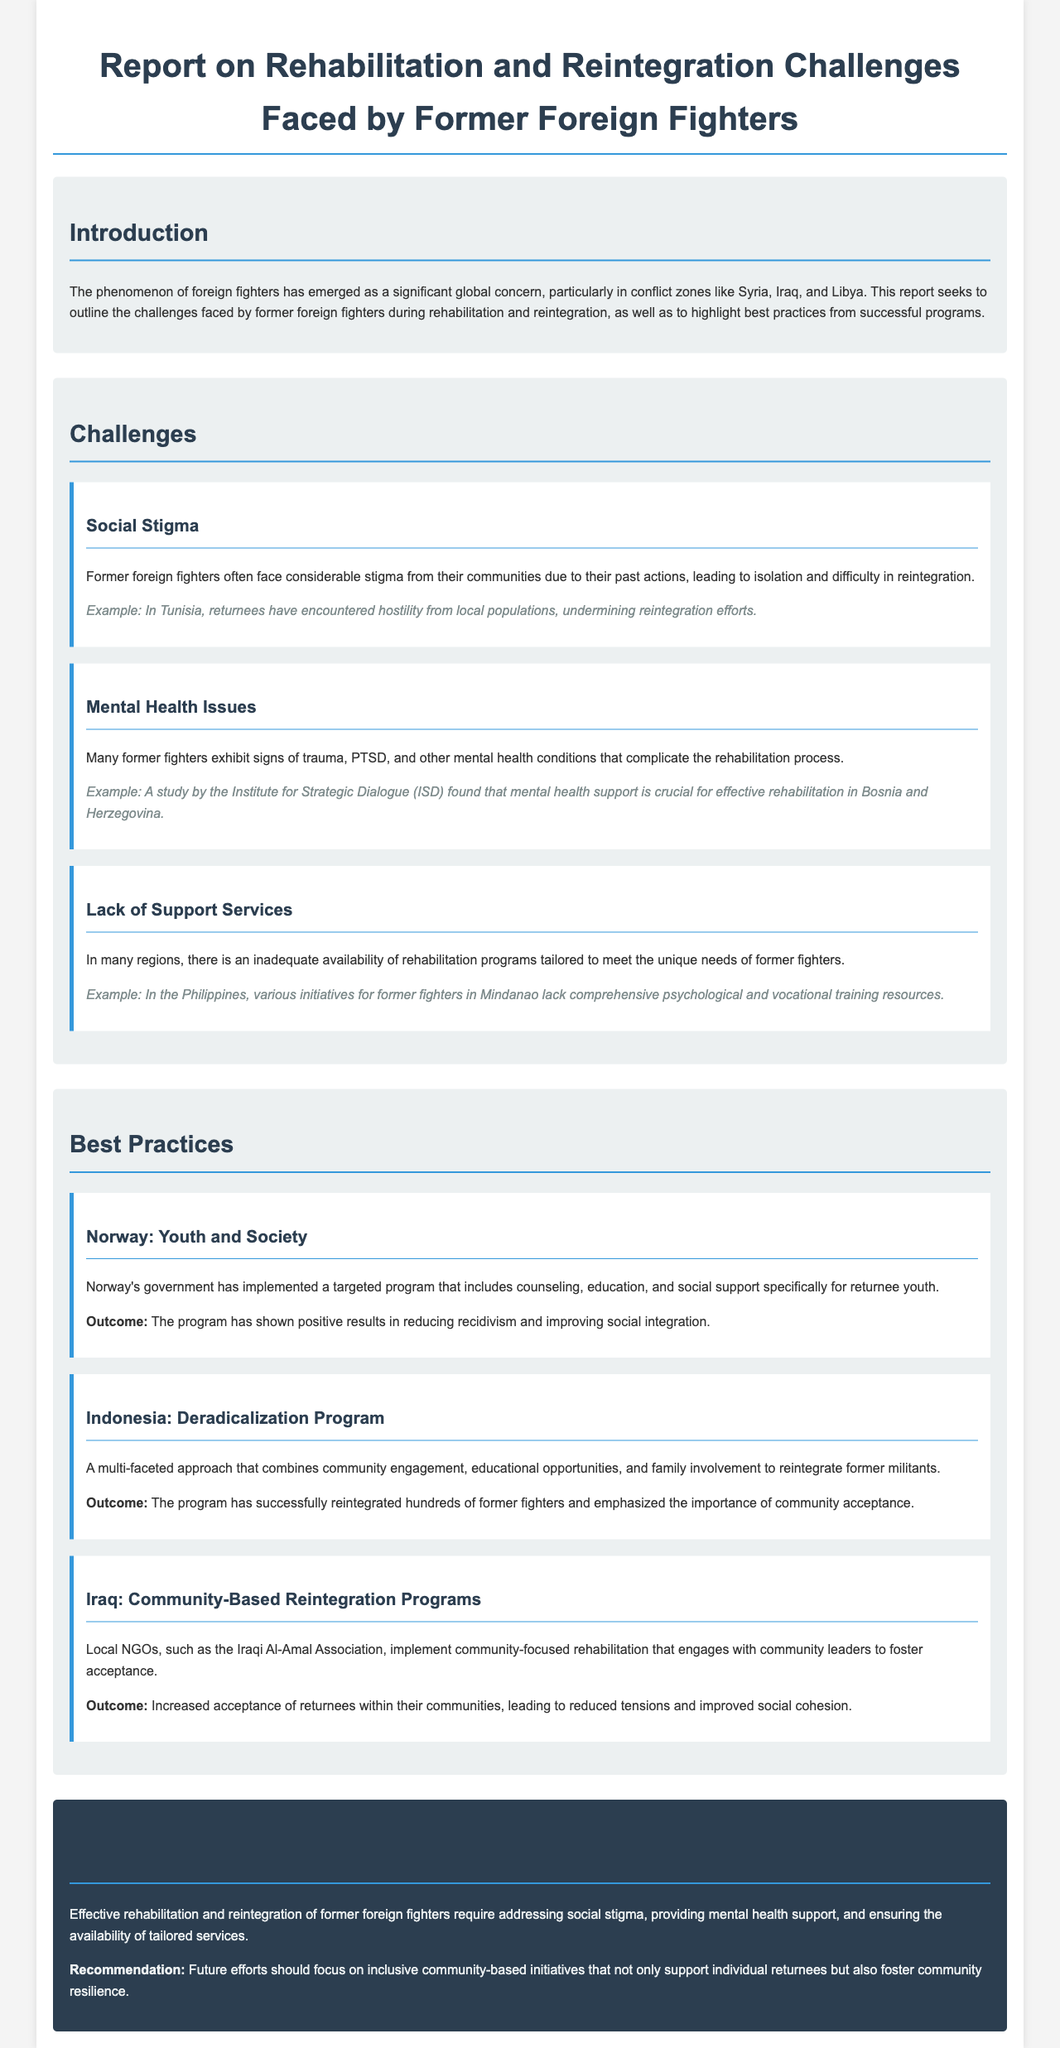What is the focus of the report? The report focuses on outlining the challenges faced by former foreign fighters during rehabilitation and reintegration and highlighting best practices from successful programs.
Answer: Rehabilitation and reintegration challenges What is one mental health issue mentioned? The report identifies trauma as a significant concern affecting former foreign fighters, complicating the rehabilitation process.
Answer: PTSD What is a challenge faced by former foreign fighters? The report lists social stigma, mental health issues, and lack of support services as challenges faced by former foreign fighters.
Answer: Social stigma Which country has a deradicalization program? The document mentions Indonesia as having a multi-faceted approach to reintegrate former militants through a deradicalization program.
Answer: Indonesia What is one outcome of the Norway program? The program implemented by Norway has resulted in a reduction in recidivism and improved social integration for returnee youth.
Answer: Reduced recidivism What is a key recommendation from the report? The report recommends focusing on inclusive community-based initiatives to support individual returnees and foster community resilience.
Answer: Community-based initiatives 